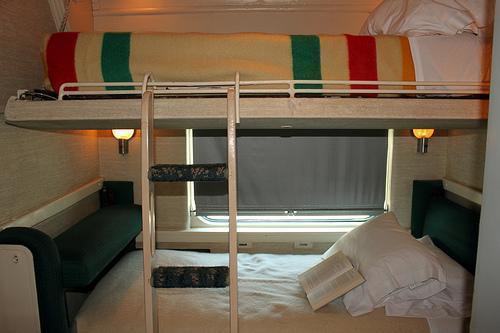How many lights are pictured?
Give a very brief answer. 2. 